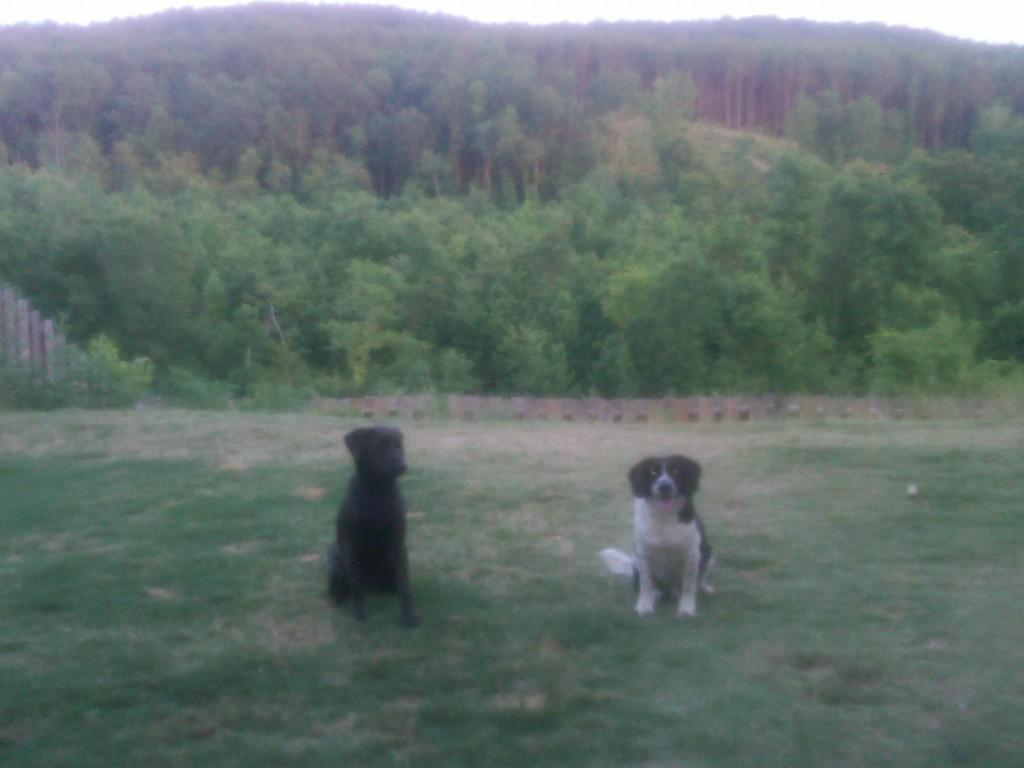What is the color scheme of the image? The image is in black and white. How many animals are present in the image? There are two animals in the image. What color are the animals in the image? The animals are in black and white color. What can be seen in the background of the image? There are trees and the sky visible in the background of the image. What color are the trees in the image? The trees are in green color. What color is the sky in the image? The sky is in white color. What type of jar is being used to collect the animals' thoughts in the image? There is no jar or indication of thoughts in the image; it features two black and white animals with trees and a white sky in the background. 